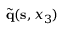Convert formula to latex. <formula><loc_0><loc_0><loc_500><loc_500>\tilde { q } ( { s } , x _ { 3 } )</formula> 